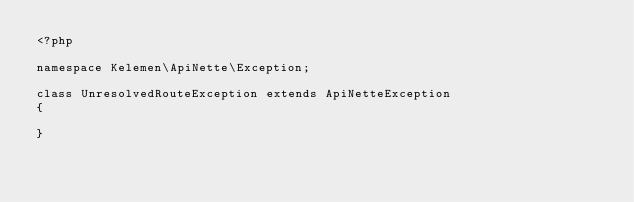Convert code to text. <code><loc_0><loc_0><loc_500><loc_500><_PHP_><?php

namespace Kelemen\ApiNette\Exception;

class UnresolvedRouteException extends ApiNetteException
{
    
}
</code> 